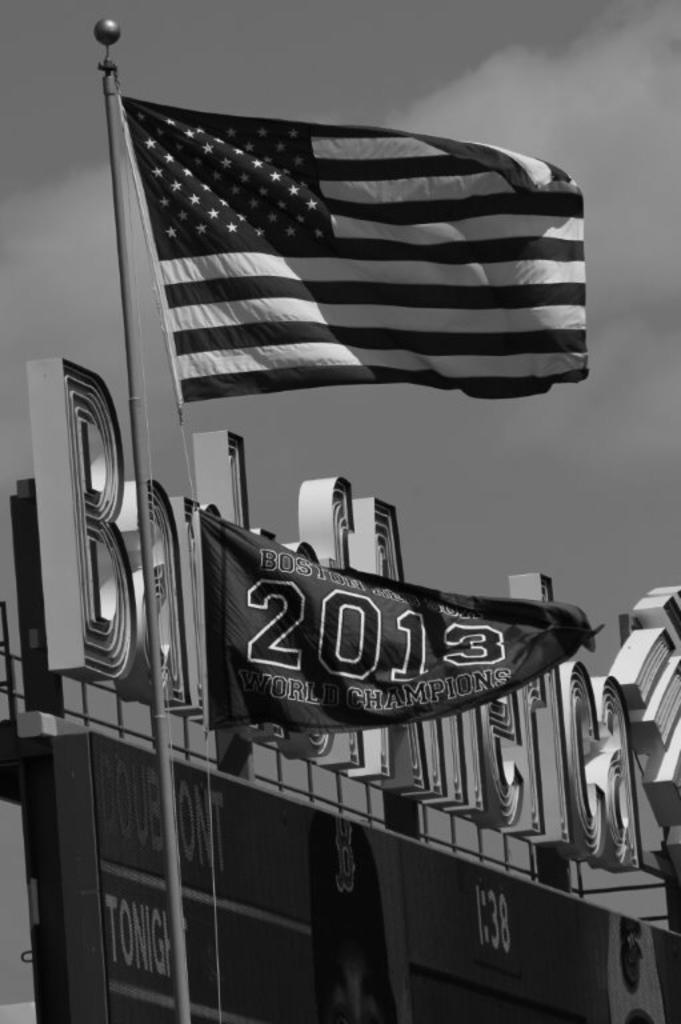<image>
Summarize the visual content of the image. The flag is American and the flag underneath it states Boston and World Champions with the year 2013. 